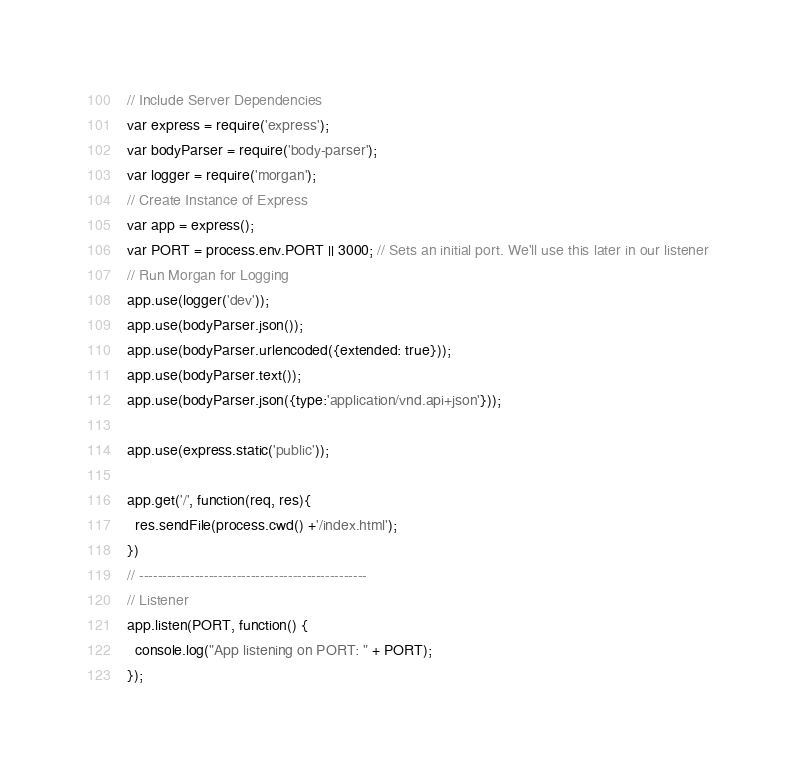<code> <loc_0><loc_0><loc_500><loc_500><_JavaScript_>// Include Server Dependencies
var express = require('express');
var bodyParser = require('body-parser');
var logger = require('morgan');
// Create Instance of Express
var app = express();
var PORT = process.env.PORT || 3000; // Sets an initial port. We'll use this later in our listener
// Run Morgan for Logging
app.use(logger('dev'));
app.use(bodyParser.json());
app.use(bodyParser.urlencoded({extended: true}));
app.use(bodyParser.text());
app.use(bodyParser.json({type:'application/vnd.api+json'}));

app.use(express.static('public'));

app.get('/', function(req, res){
  res.sendFile(process.cwd() +'/index.html');
})
// -------------------------------------------------
// Listener
app.listen(PORT, function() {
  console.log("App listening on PORT: " + PORT);
});
</code> 